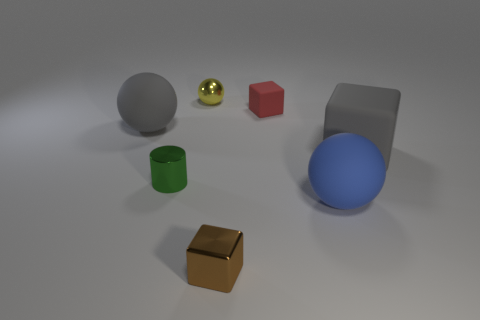Subtract all gray blocks. How many blocks are left? 2 Subtract all big matte spheres. How many spheres are left? 1 Subtract 1 blue spheres. How many objects are left? 6 Subtract all cylinders. How many objects are left? 6 Subtract 2 cubes. How many cubes are left? 1 Subtract all gray balls. Subtract all green cylinders. How many balls are left? 2 Subtract all green cylinders. How many red cubes are left? 1 Subtract all large matte blocks. Subtract all small spheres. How many objects are left? 5 Add 6 rubber balls. How many rubber balls are left? 8 Add 1 tiny brown metal objects. How many tiny brown metal objects exist? 2 